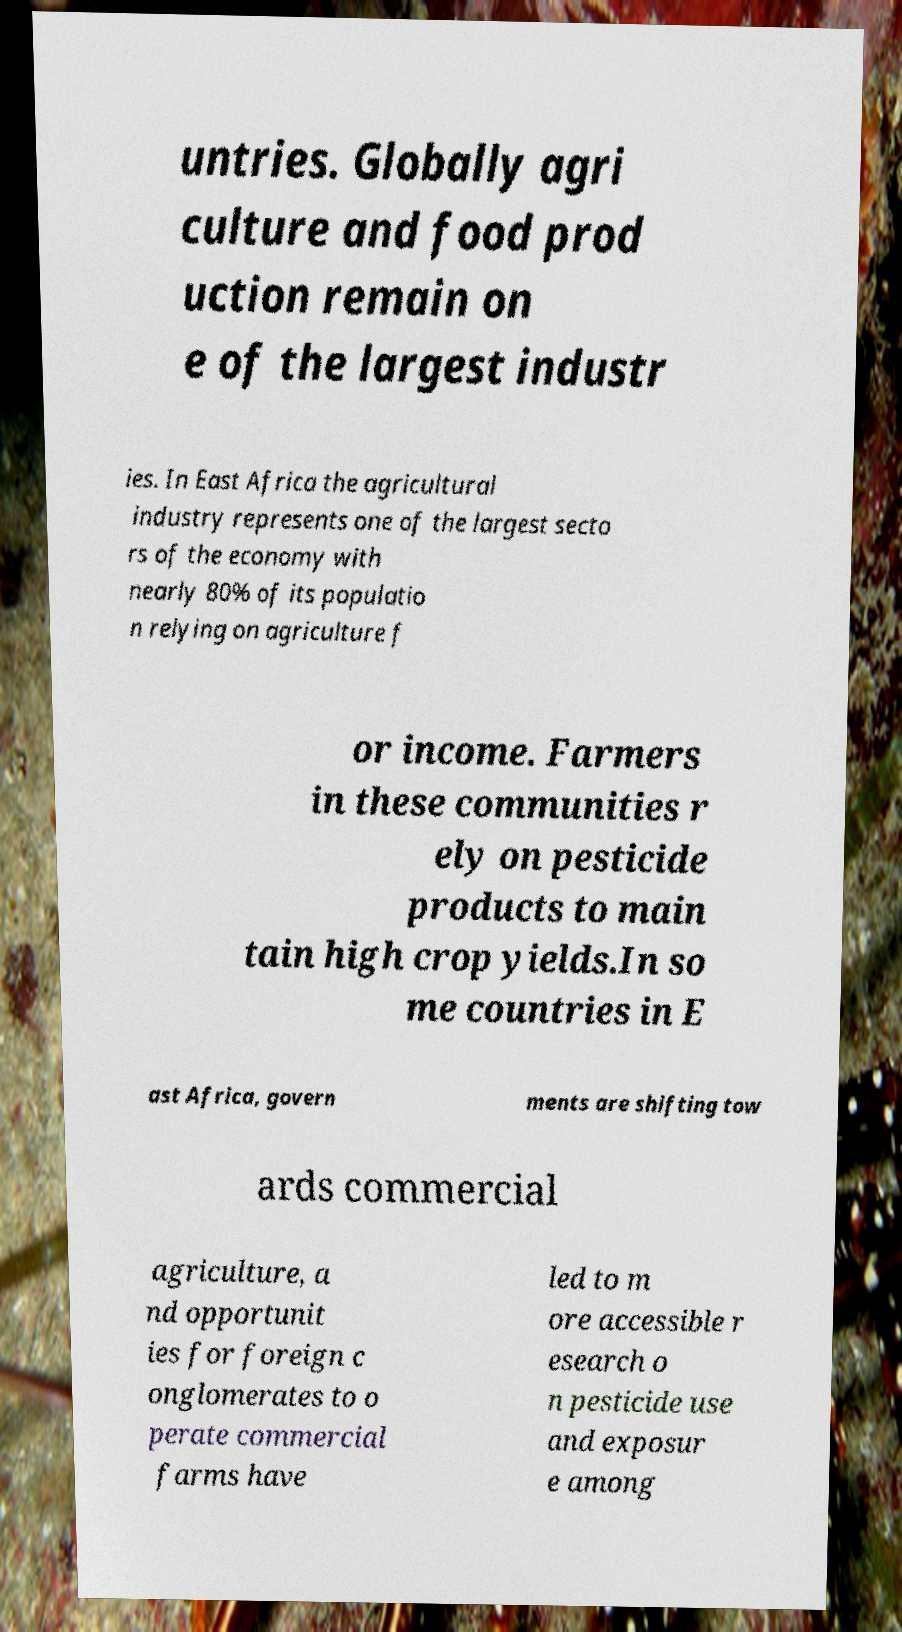What messages or text are displayed in this image? I need them in a readable, typed format. untries. Globally agri culture and food prod uction remain on e of the largest industr ies. In East Africa the agricultural industry represents one of the largest secto rs of the economy with nearly 80% of its populatio n relying on agriculture f or income. Farmers in these communities r ely on pesticide products to main tain high crop yields.In so me countries in E ast Africa, govern ments are shifting tow ards commercial agriculture, a nd opportunit ies for foreign c onglomerates to o perate commercial farms have led to m ore accessible r esearch o n pesticide use and exposur e among 